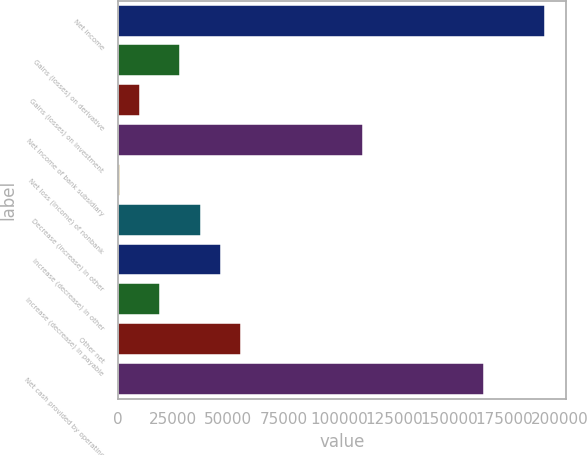<chart> <loc_0><loc_0><loc_500><loc_500><bar_chart><fcel>Net income<fcel>Gains (losses) on derivative<fcel>Gains (losses) on investment<fcel>Net income of bank subsidiary<fcel>Net loss (income) of nonbank<fcel>Decrease (increase) in other<fcel>Increase (decrease) in other<fcel>Increase (decrease) in payable<fcel>Other net<fcel>Net cash provided by operating<nl><fcel>193484<fcel>28298<fcel>9944<fcel>110891<fcel>767<fcel>37475<fcel>46652<fcel>19121<fcel>55829<fcel>165953<nl></chart> 